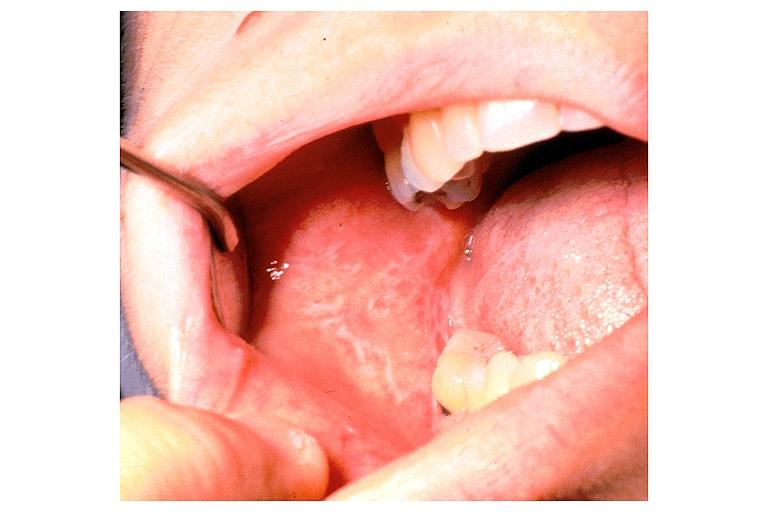s gastrointestinal present?
Answer the question using a single word or phrase. No 